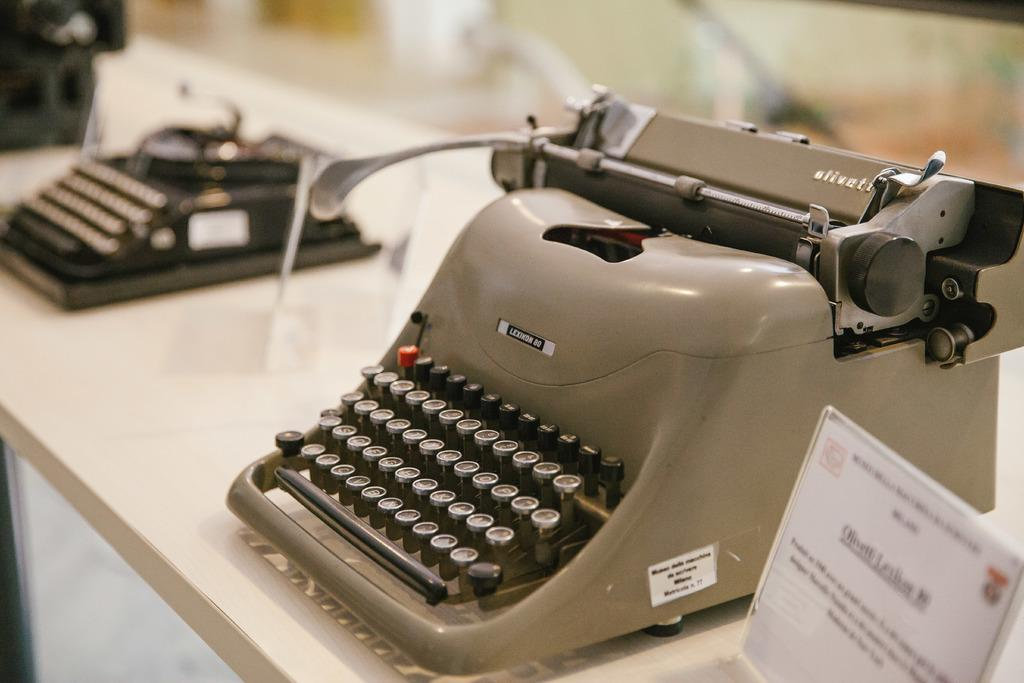<image>
Relay a brief, clear account of the picture shown. a beige typewriter on display reads Lexicon 80 